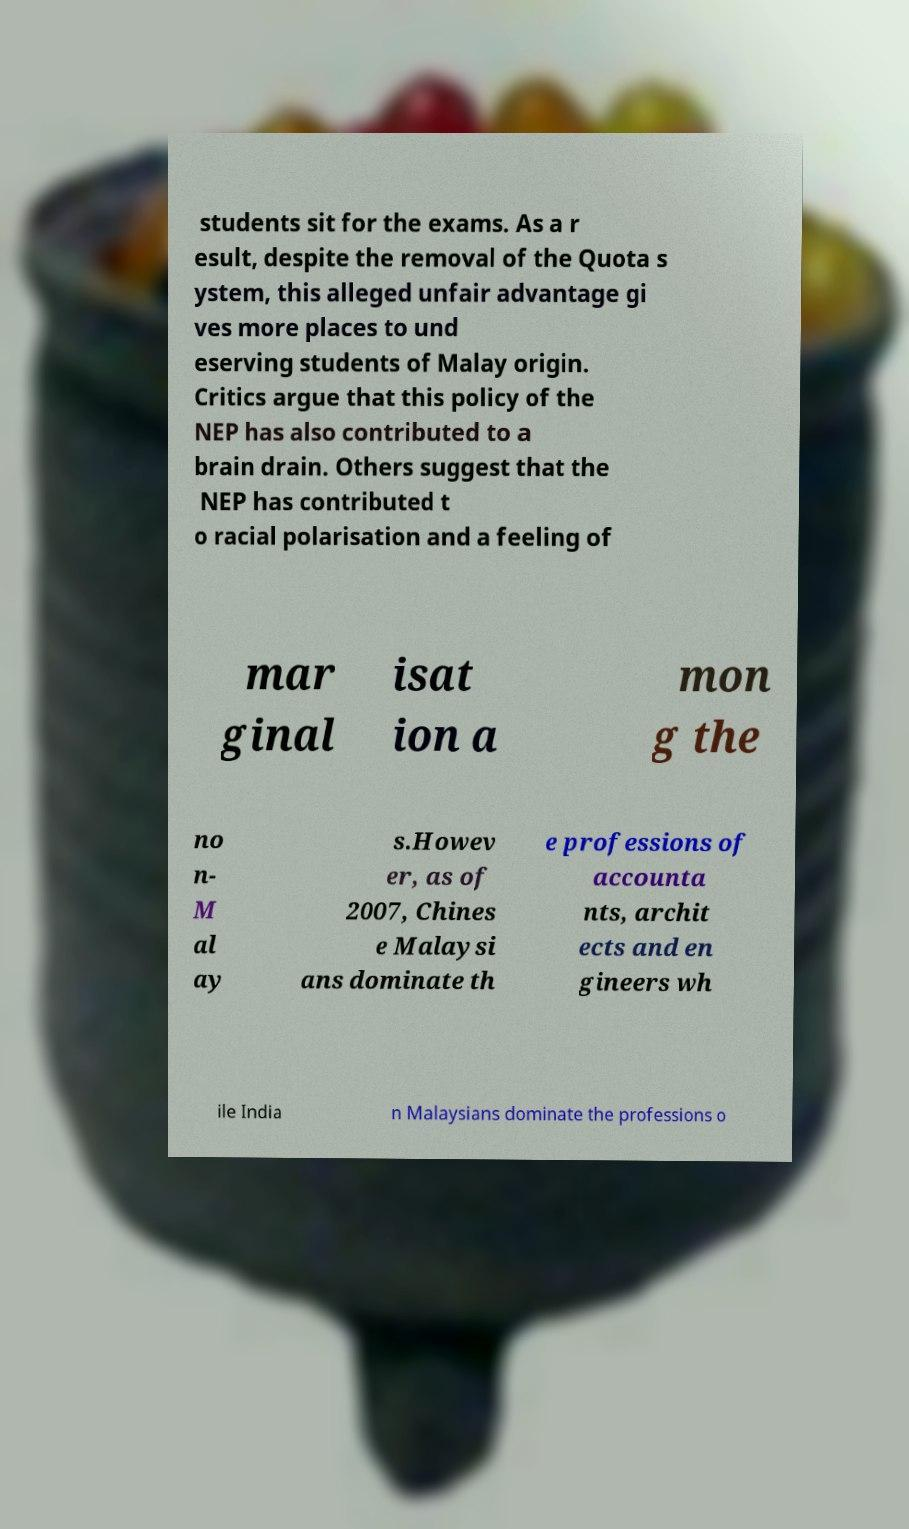Please identify and transcribe the text found in this image. students sit for the exams. As a r esult, despite the removal of the Quota s ystem, this alleged unfair advantage gi ves more places to und eserving students of Malay origin. Critics argue that this policy of the NEP has also contributed to a brain drain. Others suggest that the NEP has contributed t o racial polarisation and a feeling of mar ginal isat ion a mon g the no n- M al ay s.Howev er, as of 2007, Chines e Malaysi ans dominate th e professions of accounta nts, archit ects and en gineers wh ile India n Malaysians dominate the professions o 